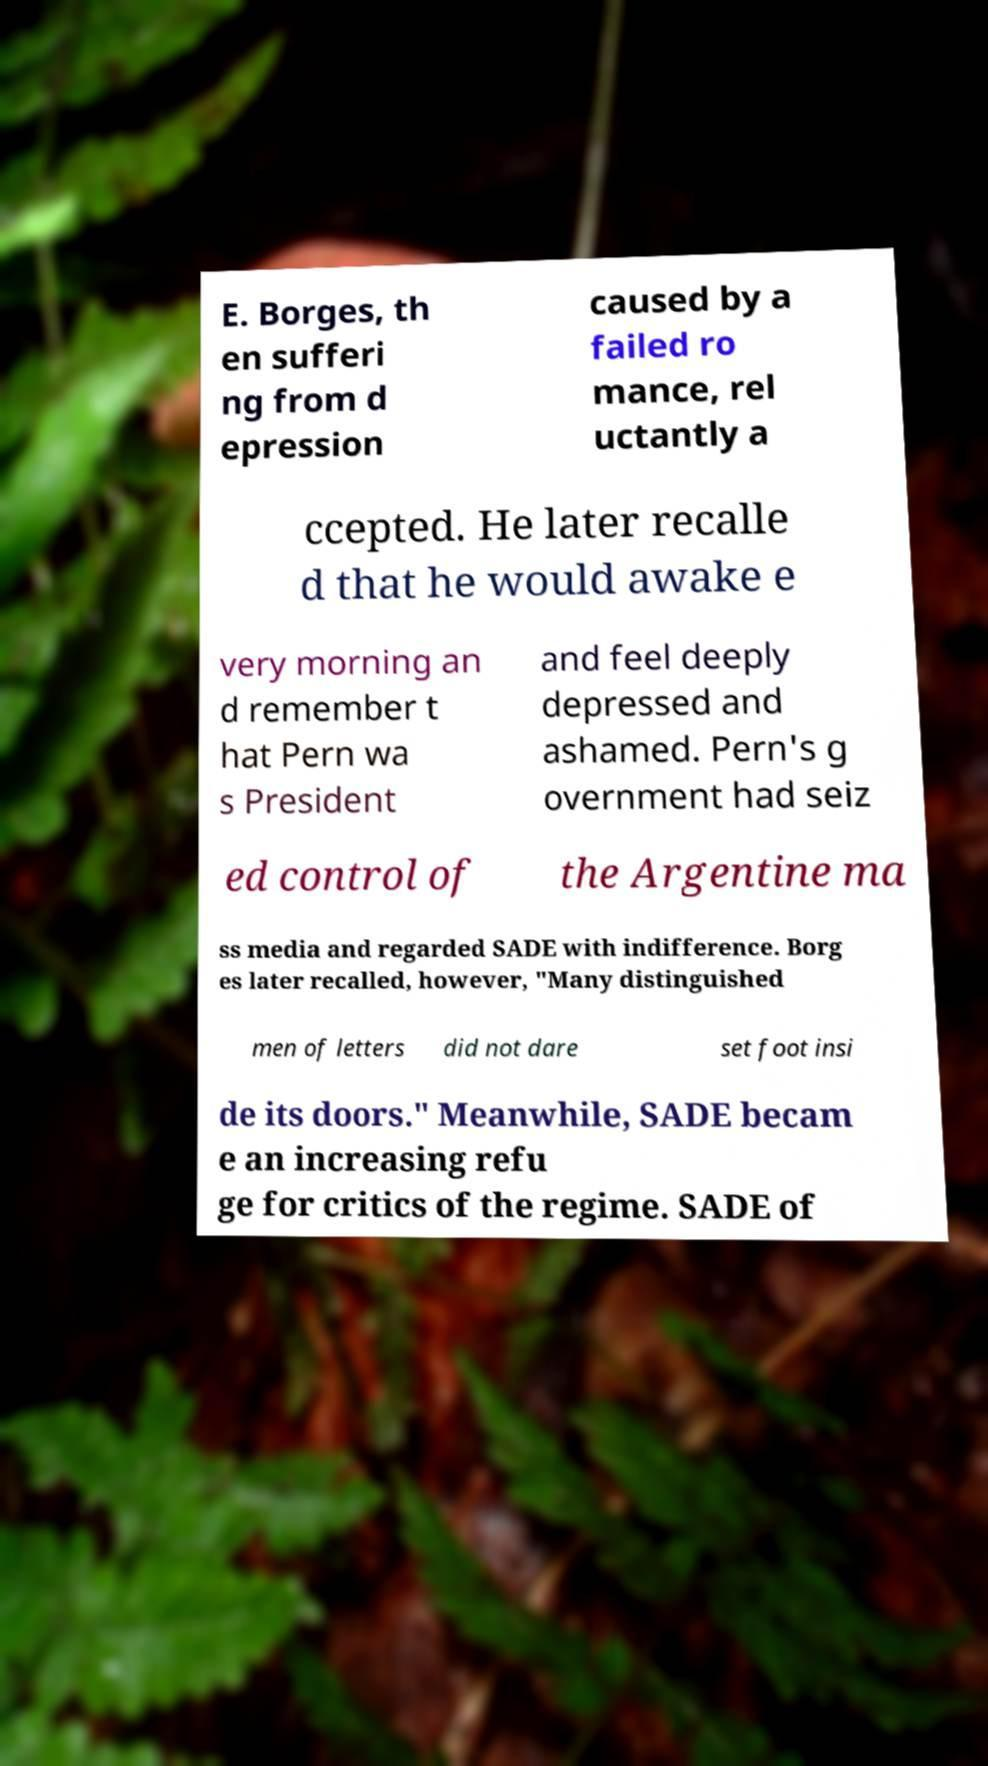There's text embedded in this image that I need extracted. Can you transcribe it verbatim? E. Borges, th en sufferi ng from d epression caused by a failed ro mance, rel uctantly a ccepted. He later recalle d that he would awake e very morning an d remember t hat Pern wa s President and feel deeply depressed and ashamed. Pern's g overnment had seiz ed control of the Argentine ma ss media and regarded SADE with indifference. Borg es later recalled, however, "Many distinguished men of letters did not dare set foot insi de its doors." Meanwhile, SADE becam e an increasing refu ge for critics of the regime. SADE of 